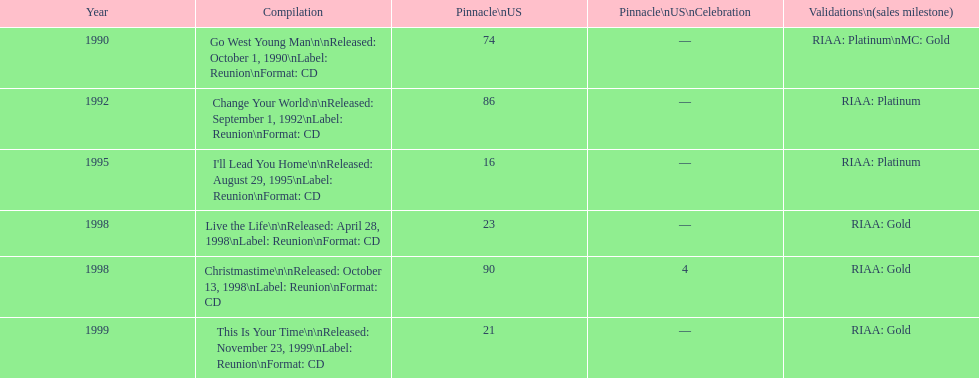How many album entries are there? 6. Parse the full table. {'header': ['Year', 'Compilation', 'Pinnacle\\nUS', 'Pinnacle\\nUS\\nCelebration', 'Validations\\n(sales milestone)'], 'rows': [['1990', 'Go West Young Man\\n\\nReleased: October 1, 1990\\nLabel: Reunion\\nFormat: CD', '74', '—', 'RIAA: Platinum\\nMC: Gold'], ['1992', 'Change Your World\\n\\nReleased: September 1, 1992\\nLabel: Reunion\\nFormat: CD', '86', '—', 'RIAA: Platinum'], ['1995', "I'll Lead You Home\\n\\nReleased: August 29, 1995\\nLabel: Reunion\\nFormat: CD", '16', '—', 'RIAA: Platinum'], ['1998', 'Live the Life\\n\\nReleased: April 28, 1998\\nLabel: Reunion\\nFormat: CD', '23', '—', 'RIAA: Gold'], ['1998', 'Christmastime\\n\\nReleased: October 13, 1998\\nLabel: Reunion\\nFormat: CD', '90', '4', 'RIAA: Gold'], ['1999', 'This Is Your Time\\n\\nReleased: November 23, 1999\\nLabel: Reunion\\nFormat: CD', '21', '—', 'RIAA: Gold']]} 